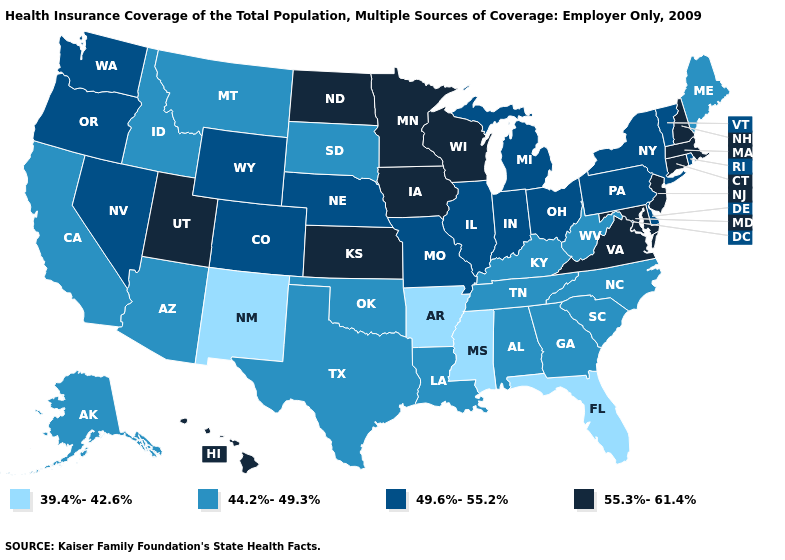Does New Mexico have the same value as Mississippi?
Answer briefly. Yes. Is the legend a continuous bar?
Quick response, please. No. Does the first symbol in the legend represent the smallest category?
Keep it brief. Yes. Among the states that border California , does Nevada have the lowest value?
Keep it brief. No. Among the states that border Delaware , does Maryland have the highest value?
Keep it brief. Yes. What is the value of Maine?
Be succinct. 44.2%-49.3%. What is the highest value in states that border Texas?
Write a very short answer. 44.2%-49.3%. Which states have the lowest value in the USA?
Keep it brief. Arkansas, Florida, Mississippi, New Mexico. What is the lowest value in the USA?
Short answer required. 39.4%-42.6%. What is the highest value in the MidWest ?
Give a very brief answer. 55.3%-61.4%. Among the states that border Kansas , does Oklahoma have the highest value?
Be succinct. No. What is the value of Arkansas?
Give a very brief answer. 39.4%-42.6%. How many symbols are there in the legend?
Concise answer only. 4. Name the states that have a value in the range 39.4%-42.6%?
Short answer required. Arkansas, Florida, Mississippi, New Mexico. Which states have the highest value in the USA?
Keep it brief. Connecticut, Hawaii, Iowa, Kansas, Maryland, Massachusetts, Minnesota, New Hampshire, New Jersey, North Dakota, Utah, Virginia, Wisconsin. 